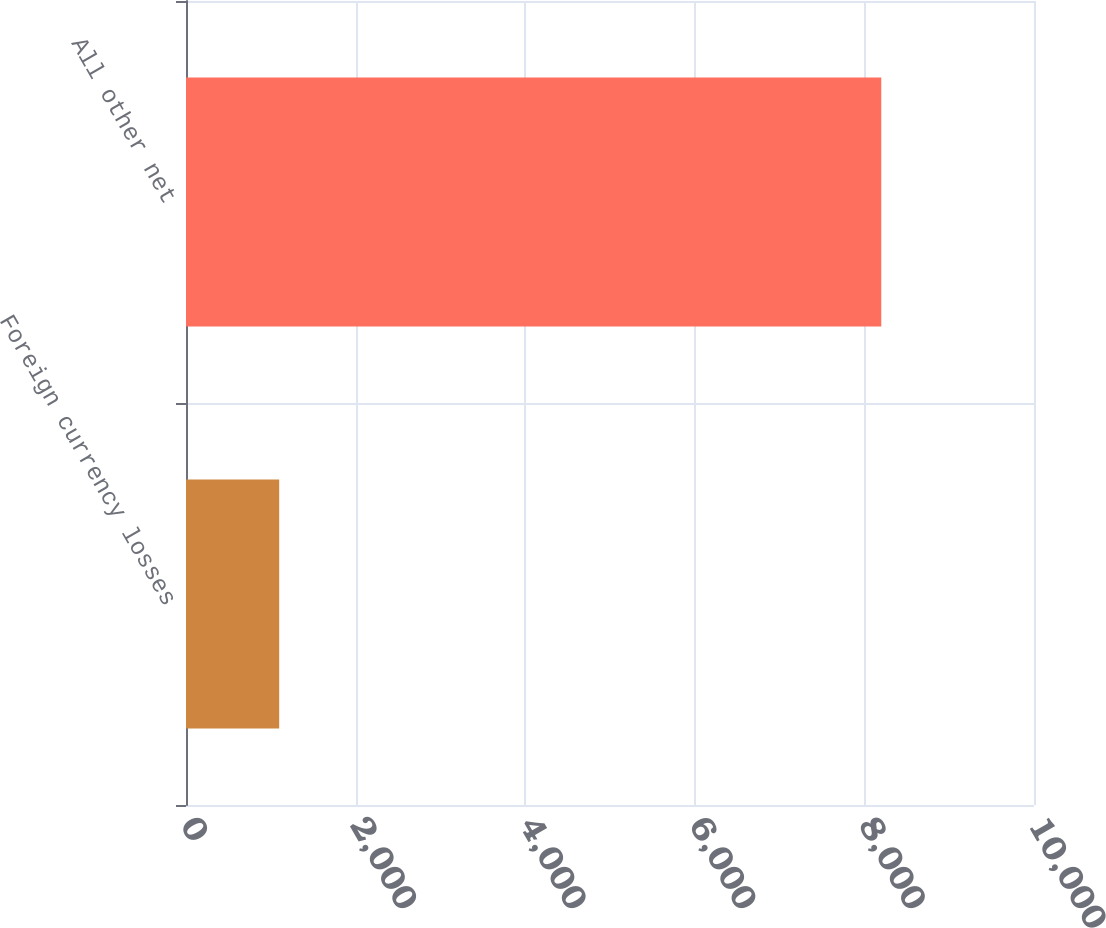Convert chart to OTSL. <chart><loc_0><loc_0><loc_500><loc_500><bar_chart><fcel>Foreign currency losses<fcel>All other net<nl><fcel>1099<fcel>8199<nl></chart> 